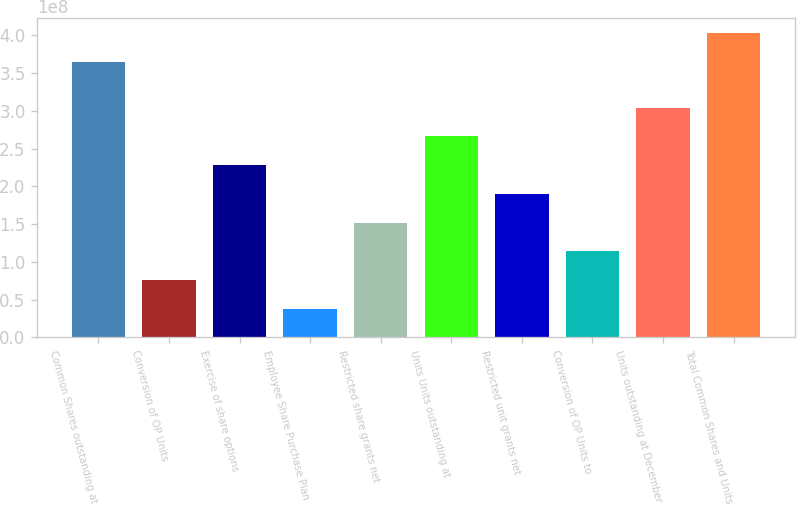Convert chart. <chart><loc_0><loc_0><loc_500><loc_500><bar_chart><fcel>Common Shares outstanding at<fcel>Conversion of OP Units<fcel>Exercise of share options<fcel>Employee Share Purchase Plan<fcel>Restricted share grants net<fcel>Units Units outstanding at<fcel>Restricted unit grants net<fcel>Conversion of OP Units to<fcel>Units outstanding at December<fcel>Total Common Shares and Units<nl><fcel>3.64755e+08<fcel>7.60994e+07<fcel>2.28298e+08<fcel>3.80497e+07<fcel>1.52199e+08<fcel>2.66348e+08<fcel>1.90249e+08<fcel>1.14149e+08<fcel>3.04398e+08<fcel>4.02805e+08<nl></chart> 